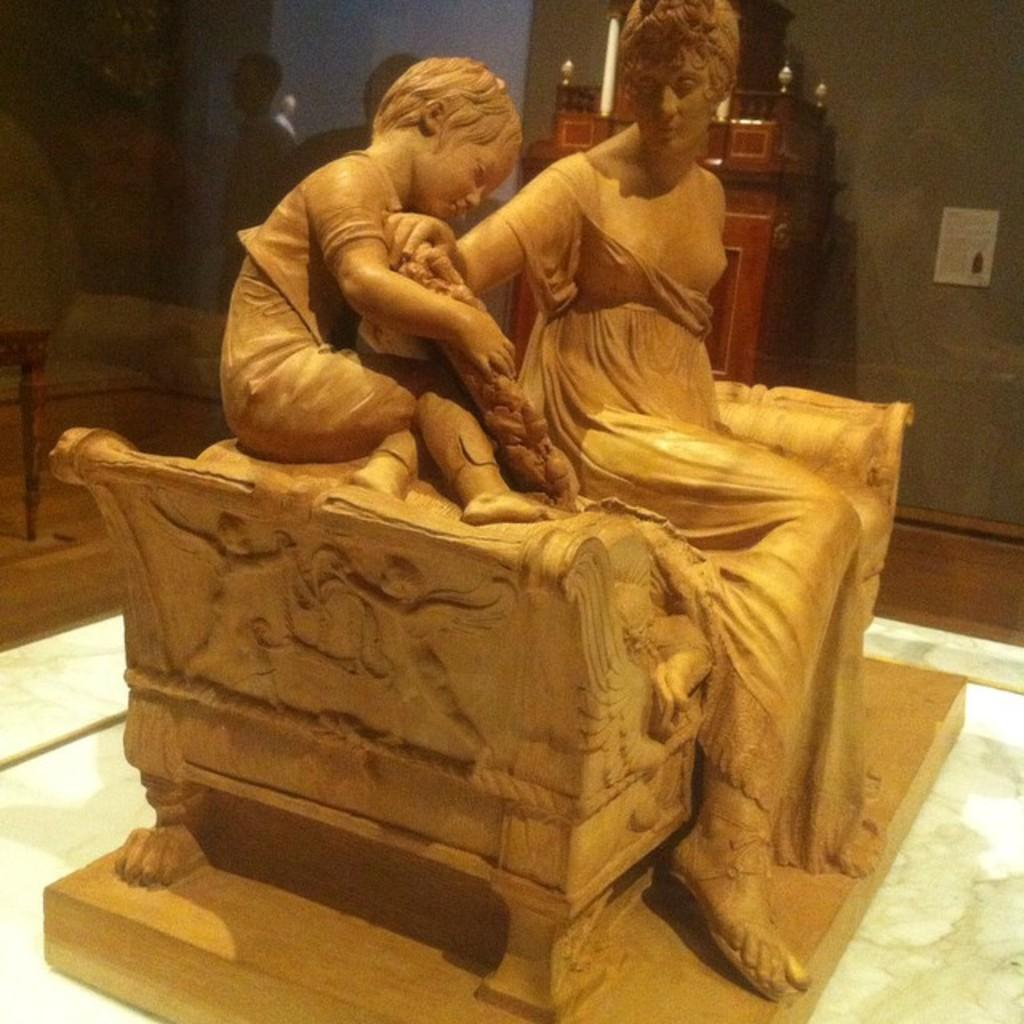What is the main subject of the image? The main subject of the image is a wooden carving of a woman sitting on a chair. Who or what is beside the woman? There is a child beside the woman. What can be seen at the left side of the image? There is a glass wall at the left side of the image. What is located at the center back of the image? There is a table at the center back of the image. How does the wooden carving contribute to the development of the child in the image? The wooden carving does not contribute to the development of the child in the image, as it is a static object and not involved in any development activities. 